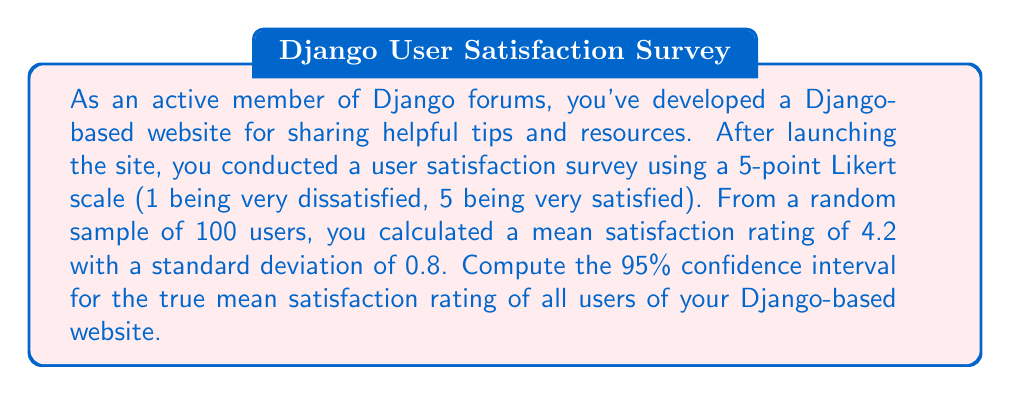What is the answer to this math problem? To compute the confidence interval, we'll use the formula:

$$\text{CI} = \bar{x} \pm t_{\alpha/2} \cdot \frac{s}{\sqrt{n}}$$

Where:
$\bar{x}$ = sample mean
$t_{\alpha/2}$ = t-value for 95% confidence level with n-1 degrees of freedom
$s$ = sample standard deviation
$n$ = sample size

Given:
$\bar{x} = 4.2$
$s = 0.8$
$n = 100$
Confidence level = 95%

Steps:
1. Find the t-value:
   With 95% confidence and 99 degrees of freedom (n-1), $t_{\alpha/2} \approx 1.984$ (from t-distribution table)

2. Calculate the margin of error:
   $$\text{Margin of Error} = t_{\alpha/2} \cdot \frac{s}{\sqrt{n}} = 1.984 \cdot \frac{0.8}{\sqrt{100}} = 0.158$$

3. Compute the confidence interval:
   $$\text{CI} = 4.2 \pm 0.158$$

4. Express the final result:
   Lower bound: $4.2 - 0.158 = 4.042$
   Upper bound: $4.2 + 0.158 = 4.358$
Answer: The 95% confidence interval for the true mean satisfaction rating is (4.042, 4.358). 